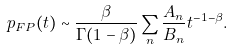Convert formula to latex. <formula><loc_0><loc_0><loc_500><loc_500>p _ { F P } ( t ) \sim \frac { \beta } { \Gamma ( 1 - \beta ) } \sum _ { n } \frac { A _ { n } } { B _ { n } } t ^ { - 1 - \beta } .</formula> 